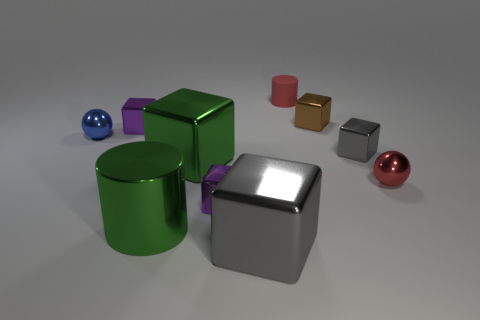There is a cylinder that is the same size as the blue thing; what material is it?
Provide a succinct answer. Rubber. Are there any matte cylinders to the right of the large gray cube?
Keep it short and to the point. Yes. Are there an equal number of tiny spheres that are left of the tiny brown metallic object and tiny blocks?
Provide a short and direct response. No. There is a brown thing that is the same size as the blue metal thing; what shape is it?
Keep it short and to the point. Cube. What material is the tiny red cylinder?
Provide a succinct answer. Rubber. What color is the block that is both right of the big green cylinder and behind the tiny gray object?
Ensure brevity in your answer.  Brown. Are there the same number of big green cylinders that are in front of the big gray thing and tiny purple objects in front of the tiny gray metal object?
Offer a very short reply. No. What color is the cylinder that is made of the same material as the tiny blue thing?
Provide a short and direct response. Green. Does the small matte object have the same color as the small shiny ball that is left of the brown cube?
Provide a short and direct response. No. There is a sphere that is to the left of the red object that is left of the small brown metal block; are there any tiny purple cubes that are behind it?
Your answer should be compact. Yes. 